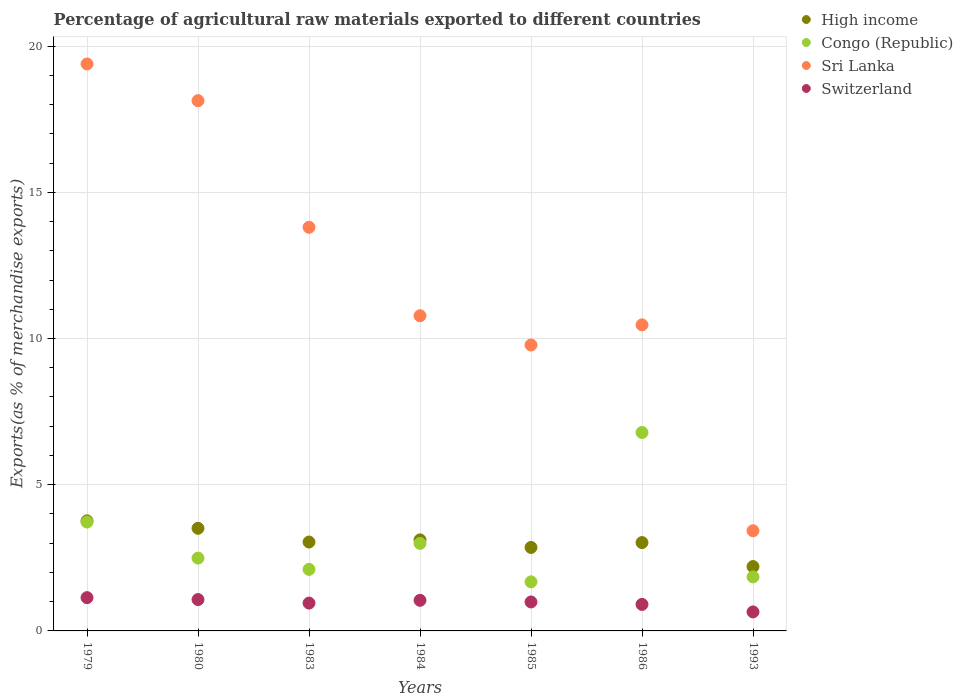How many different coloured dotlines are there?
Your answer should be compact. 4. Is the number of dotlines equal to the number of legend labels?
Keep it short and to the point. Yes. What is the percentage of exports to different countries in High income in 1984?
Your response must be concise. 3.11. Across all years, what is the maximum percentage of exports to different countries in Congo (Republic)?
Your answer should be compact. 6.79. Across all years, what is the minimum percentage of exports to different countries in Switzerland?
Provide a succinct answer. 0.65. In which year was the percentage of exports to different countries in Switzerland maximum?
Offer a very short reply. 1979. In which year was the percentage of exports to different countries in Sri Lanka minimum?
Your response must be concise. 1993. What is the total percentage of exports to different countries in Switzerland in the graph?
Make the answer very short. 6.76. What is the difference between the percentage of exports to different countries in High income in 1984 and that in 1986?
Your answer should be compact. 0.09. What is the difference between the percentage of exports to different countries in Sri Lanka in 1979 and the percentage of exports to different countries in High income in 1986?
Keep it short and to the point. 16.37. What is the average percentage of exports to different countries in High income per year?
Give a very brief answer. 3.07. In the year 1993, what is the difference between the percentage of exports to different countries in Congo (Republic) and percentage of exports to different countries in Switzerland?
Provide a short and direct response. 1.2. In how many years, is the percentage of exports to different countries in Sri Lanka greater than 16 %?
Your answer should be compact. 2. What is the ratio of the percentage of exports to different countries in Sri Lanka in 1984 to that in 1985?
Offer a very short reply. 1.1. Is the percentage of exports to different countries in Switzerland in 1980 less than that in 1983?
Provide a succinct answer. No. Is the difference between the percentage of exports to different countries in Congo (Republic) in 1980 and 1986 greater than the difference between the percentage of exports to different countries in Switzerland in 1980 and 1986?
Offer a very short reply. No. What is the difference between the highest and the second highest percentage of exports to different countries in High income?
Ensure brevity in your answer.  0.26. What is the difference between the highest and the lowest percentage of exports to different countries in Congo (Republic)?
Keep it short and to the point. 5.11. In how many years, is the percentage of exports to different countries in High income greater than the average percentage of exports to different countries in High income taken over all years?
Ensure brevity in your answer.  3. Is the sum of the percentage of exports to different countries in High income in 1984 and 1985 greater than the maximum percentage of exports to different countries in Sri Lanka across all years?
Your answer should be very brief. No. Is it the case that in every year, the sum of the percentage of exports to different countries in Switzerland and percentage of exports to different countries in Congo (Republic)  is greater than the percentage of exports to different countries in High income?
Your response must be concise. No. Does the percentage of exports to different countries in Sri Lanka monotonically increase over the years?
Make the answer very short. No. Is the percentage of exports to different countries in Sri Lanka strictly less than the percentage of exports to different countries in High income over the years?
Your answer should be very brief. No. How many dotlines are there?
Provide a short and direct response. 4. What is the difference between two consecutive major ticks on the Y-axis?
Give a very brief answer. 5. Are the values on the major ticks of Y-axis written in scientific E-notation?
Make the answer very short. No. What is the title of the graph?
Your answer should be very brief. Percentage of agricultural raw materials exported to different countries. What is the label or title of the Y-axis?
Provide a succinct answer. Exports(as % of merchandise exports). What is the Exports(as % of merchandise exports) of High income in 1979?
Your response must be concise. 3.76. What is the Exports(as % of merchandise exports) of Congo (Republic) in 1979?
Offer a very short reply. 3.72. What is the Exports(as % of merchandise exports) in Sri Lanka in 1979?
Your answer should be compact. 19.39. What is the Exports(as % of merchandise exports) of Switzerland in 1979?
Offer a terse response. 1.14. What is the Exports(as % of merchandise exports) of High income in 1980?
Give a very brief answer. 3.51. What is the Exports(as % of merchandise exports) of Congo (Republic) in 1980?
Provide a short and direct response. 2.49. What is the Exports(as % of merchandise exports) of Sri Lanka in 1980?
Give a very brief answer. 18.13. What is the Exports(as % of merchandise exports) of Switzerland in 1980?
Give a very brief answer. 1.07. What is the Exports(as % of merchandise exports) in High income in 1983?
Offer a very short reply. 3.04. What is the Exports(as % of merchandise exports) of Congo (Republic) in 1983?
Offer a terse response. 2.1. What is the Exports(as % of merchandise exports) in Sri Lanka in 1983?
Keep it short and to the point. 13.8. What is the Exports(as % of merchandise exports) in Switzerland in 1983?
Offer a terse response. 0.95. What is the Exports(as % of merchandise exports) in High income in 1984?
Your answer should be very brief. 3.11. What is the Exports(as % of merchandise exports) of Congo (Republic) in 1984?
Your answer should be compact. 2.99. What is the Exports(as % of merchandise exports) of Sri Lanka in 1984?
Provide a short and direct response. 10.78. What is the Exports(as % of merchandise exports) in Switzerland in 1984?
Your answer should be compact. 1.05. What is the Exports(as % of merchandise exports) of High income in 1985?
Offer a very short reply. 2.85. What is the Exports(as % of merchandise exports) in Congo (Republic) in 1985?
Ensure brevity in your answer.  1.68. What is the Exports(as % of merchandise exports) of Sri Lanka in 1985?
Offer a terse response. 9.78. What is the Exports(as % of merchandise exports) in Switzerland in 1985?
Offer a terse response. 0.99. What is the Exports(as % of merchandise exports) of High income in 1986?
Your answer should be very brief. 3.02. What is the Exports(as % of merchandise exports) in Congo (Republic) in 1986?
Make the answer very short. 6.79. What is the Exports(as % of merchandise exports) in Sri Lanka in 1986?
Offer a terse response. 10.47. What is the Exports(as % of merchandise exports) of Switzerland in 1986?
Offer a terse response. 0.91. What is the Exports(as % of merchandise exports) in High income in 1993?
Provide a succinct answer. 2.2. What is the Exports(as % of merchandise exports) in Congo (Republic) in 1993?
Keep it short and to the point. 1.85. What is the Exports(as % of merchandise exports) in Sri Lanka in 1993?
Offer a very short reply. 3.43. What is the Exports(as % of merchandise exports) in Switzerland in 1993?
Your answer should be very brief. 0.65. Across all years, what is the maximum Exports(as % of merchandise exports) of High income?
Provide a succinct answer. 3.76. Across all years, what is the maximum Exports(as % of merchandise exports) of Congo (Republic)?
Make the answer very short. 6.79. Across all years, what is the maximum Exports(as % of merchandise exports) in Sri Lanka?
Make the answer very short. 19.39. Across all years, what is the maximum Exports(as % of merchandise exports) of Switzerland?
Your response must be concise. 1.14. Across all years, what is the minimum Exports(as % of merchandise exports) in High income?
Ensure brevity in your answer.  2.2. Across all years, what is the minimum Exports(as % of merchandise exports) of Congo (Republic)?
Make the answer very short. 1.68. Across all years, what is the minimum Exports(as % of merchandise exports) in Sri Lanka?
Provide a succinct answer. 3.43. Across all years, what is the minimum Exports(as % of merchandise exports) of Switzerland?
Your answer should be compact. 0.65. What is the total Exports(as % of merchandise exports) of High income in the graph?
Give a very brief answer. 21.5. What is the total Exports(as % of merchandise exports) in Congo (Republic) in the graph?
Provide a succinct answer. 21.62. What is the total Exports(as % of merchandise exports) in Sri Lanka in the graph?
Provide a succinct answer. 85.77. What is the total Exports(as % of merchandise exports) of Switzerland in the graph?
Keep it short and to the point. 6.76. What is the difference between the Exports(as % of merchandise exports) in High income in 1979 and that in 1980?
Offer a very short reply. 0.26. What is the difference between the Exports(as % of merchandise exports) in Congo (Republic) in 1979 and that in 1980?
Provide a short and direct response. 1.23. What is the difference between the Exports(as % of merchandise exports) in Sri Lanka in 1979 and that in 1980?
Your answer should be very brief. 1.25. What is the difference between the Exports(as % of merchandise exports) in Switzerland in 1979 and that in 1980?
Give a very brief answer. 0.07. What is the difference between the Exports(as % of merchandise exports) of High income in 1979 and that in 1983?
Your answer should be compact. 0.73. What is the difference between the Exports(as % of merchandise exports) of Congo (Republic) in 1979 and that in 1983?
Ensure brevity in your answer.  1.62. What is the difference between the Exports(as % of merchandise exports) of Sri Lanka in 1979 and that in 1983?
Offer a terse response. 5.58. What is the difference between the Exports(as % of merchandise exports) in Switzerland in 1979 and that in 1983?
Your answer should be compact. 0.19. What is the difference between the Exports(as % of merchandise exports) of High income in 1979 and that in 1984?
Offer a very short reply. 0.65. What is the difference between the Exports(as % of merchandise exports) of Congo (Republic) in 1979 and that in 1984?
Give a very brief answer. 0.73. What is the difference between the Exports(as % of merchandise exports) of Sri Lanka in 1979 and that in 1984?
Keep it short and to the point. 8.61. What is the difference between the Exports(as % of merchandise exports) in Switzerland in 1979 and that in 1984?
Ensure brevity in your answer.  0.09. What is the difference between the Exports(as % of merchandise exports) of High income in 1979 and that in 1985?
Make the answer very short. 0.91. What is the difference between the Exports(as % of merchandise exports) of Congo (Republic) in 1979 and that in 1985?
Your answer should be compact. 2.04. What is the difference between the Exports(as % of merchandise exports) in Sri Lanka in 1979 and that in 1985?
Your response must be concise. 9.61. What is the difference between the Exports(as % of merchandise exports) of Switzerland in 1979 and that in 1985?
Give a very brief answer. 0.15. What is the difference between the Exports(as % of merchandise exports) in High income in 1979 and that in 1986?
Your response must be concise. 0.74. What is the difference between the Exports(as % of merchandise exports) of Congo (Republic) in 1979 and that in 1986?
Offer a very short reply. -3.06. What is the difference between the Exports(as % of merchandise exports) in Sri Lanka in 1979 and that in 1986?
Make the answer very short. 8.92. What is the difference between the Exports(as % of merchandise exports) in Switzerland in 1979 and that in 1986?
Make the answer very short. 0.23. What is the difference between the Exports(as % of merchandise exports) in High income in 1979 and that in 1993?
Your answer should be very brief. 1.56. What is the difference between the Exports(as % of merchandise exports) of Congo (Republic) in 1979 and that in 1993?
Your response must be concise. 1.87. What is the difference between the Exports(as % of merchandise exports) in Sri Lanka in 1979 and that in 1993?
Your response must be concise. 15.96. What is the difference between the Exports(as % of merchandise exports) of Switzerland in 1979 and that in 1993?
Your answer should be very brief. 0.49. What is the difference between the Exports(as % of merchandise exports) of High income in 1980 and that in 1983?
Keep it short and to the point. 0.47. What is the difference between the Exports(as % of merchandise exports) of Congo (Republic) in 1980 and that in 1983?
Ensure brevity in your answer.  0.39. What is the difference between the Exports(as % of merchandise exports) in Sri Lanka in 1980 and that in 1983?
Provide a succinct answer. 4.33. What is the difference between the Exports(as % of merchandise exports) of Switzerland in 1980 and that in 1983?
Provide a short and direct response. 0.12. What is the difference between the Exports(as % of merchandise exports) of High income in 1980 and that in 1984?
Offer a very short reply. 0.4. What is the difference between the Exports(as % of merchandise exports) in Congo (Republic) in 1980 and that in 1984?
Ensure brevity in your answer.  -0.5. What is the difference between the Exports(as % of merchandise exports) in Sri Lanka in 1980 and that in 1984?
Offer a terse response. 7.35. What is the difference between the Exports(as % of merchandise exports) of Switzerland in 1980 and that in 1984?
Keep it short and to the point. 0.03. What is the difference between the Exports(as % of merchandise exports) in High income in 1980 and that in 1985?
Your answer should be very brief. 0.65. What is the difference between the Exports(as % of merchandise exports) in Congo (Republic) in 1980 and that in 1985?
Your answer should be very brief. 0.81. What is the difference between the Exports(as % of merchandise exports) of Sri Lanka in 1980 and that in 1985?
Provide a short and direct response. 8.36. What is the difference between the Exports(as % of merchandise exports) of Switzerland in 1980 and that in 1985?
Give a very brief answer. 0.08. What is the difference between the Exports(as % of merchandise exports) of High income in 1980 and that in 1986?
Offer a very short reply. 0.49. What is the difference between the Exports(as % of merchandise exports) in Congo (Republic) in 1980 and that in 1986?
Ensure brevity in your answer.  -4.3. What is the difference between the Exports(as % of merchandise exports) of Sri Lanka in 1980 and that in 1986?
Give a very brief answer. 7.67. What is the difference between the Exports(as % of merchandise exports) of Switzerland in 1980 and that in 1986?
Provide a short and direct response. 0.17. What is the difference between the Exports(as % of merchandise exports) of High income in 1980 and that in 1993?
Provide a short and direct response. 1.31. What is the difference between the Exports(as % of merchandise exports) in Congo (Republic) in 1980 and that in 1993?
Keep it short and to the point. 0.64. What is the difference between the Exports(as % of merchandise exports) in Sri Lanka in 1980 and that in 1993?
Keep it short and to the point. 14.71. What is the difference between the Exports(as % of merchandise exports) in Switzerland in 1980 and that in 1993?
Offer a terse response. 0.42. What is the difference between the Exports(as % of merchandise exports) of High income in 1983 and that in 1984?
Offer a terse response. -0.07. What is the difference between the Exports(as % of merchandise exports) in Congo (Republic) in 1983 and that in 1984?
Your answer should be compact. -0.89. What is the difference between the Exports(as % of merchandise exports) of Sri Lanka in 1983 and that in 1984?
Make the answer very short. 3.02. What is the difference between the Exports(as % of merchandise exports) in Switzerland in 1983 and that in 1984?
Keep it short and to the point. -0.09. What is the difference between the Exports(as % of merchandise exports) of High income in 1983 and that in 1985?
Provide a short and direct response. 0.18. What is the difference between the Exports(as % of merchandise exports) in Congo (Republic) in 1983 and that in 1985?
Give a very brief answer. 0.43. What is the difference between the Exports(as % of merchandise exports) in Sri Lanka in 1983 and that in 1985?
Offer a very short reply. 4.03. What is the difference between the Exports(as % of merchandise exports) in Switzerland in 1983 and that in 1985?
Provide a succinct answer. -0.04. What is the difference between the Exports(as % of merchandise exports) in High income in 1983 and that in 1986?
Your response must be concise. 0.02. What is the difference between the Exports(as % of merchandise exports) in Congo (Republic) in 1983 and that in 1986?
Offer a terse response. -4.68. What is the difference between the Exports(as % of merchandise exports) of Sri Lanka in 1983 and that in 1986?
Ensure brevity in your answer.  3.34. What is the difference between the Exports(as % of merchandise exports) in Switzerland in 1983 and that in 1986?
Your answer should be compact. 0.04. What is the difference between the Exports(as % of merchandise exports) of High income in 1983 and that in 1993?
Your answer should be compact. 0.84. What is the difference between the Exports(as % of merchandise exports) of Congo (Republic) in 1983 and that in 1993?
Offer a very short reply. 0.26. What is the difference between the Exports(as % of merchandise exports) of Sri Lanka in 1983 and that in 1993?
Offer a terse response. 10.38. What is the difference between the Exports(as % of merchandise exports) of Switzerland in 1983 and that in 1993?
Your answer should be very brief. 0.3. What is the difference between the Exports(as % of merchandise exports) in High income in 1984 and that in 1985?
Offer a terse response. 0.26. What is the difference between the Exports(as % of merchandise exports) of Congo (Republic) in 1984 and that in 1985?
Your answer should be compact. 1.32. What is the difference between the Exports(as % of merchandise exports) of Sri Lanka in 1984 and that in 1985?
Provide a succinct answer. 1. What is the difference between the Exports(as % of merchandise exports) of Switzerland in 1984 and that in 1985?
Offer a very short reply. 0.06. What is the difference between the Exports(as % of merchandise exports) in High income in 1984 and that in 1986?
Your response must be concise. 0.09. What is the difference between the Exports(as % of merchandise exports) of Congo (Republic) in 1984 and that in 1986?
Make the answer very short. -3.79. What is the difference between the Exports(as % of merchandise exports) of Sri Lanka in 1984 and that in 1986?
Ensure brevity in your answer.  0.31. What is the difference between the Exports(as % of merchandise exports) of Switzerland in 1984 and that in 1986?
Keep it short and to the point. 0.14. What is the difference between the Exports(as % of merchandise exports) in High income in 1984 and that in 1993?
Offer a very short reply. 0.91. What is the difference between the Exports(as % of merchandise exports) of Congo (Republic) in 1984 and that in 1993?
Keep it short and to the point. 1.15. What is the difference between the Exports(as % of merchandise exports) of Sri Lanka in 1984 and that in 1993?
Provide a succinct answer. 7.35. What is the difference between the Exports(as % of merchandise exports) in Switzerland in 1984 and that in 1993?
Your answer should be compact. 0.4. What is the difference between the Exports(as % of merchandise exports) in High income in 1985 and that in 1986?
Offer a terse response. -0.17. What is the difference between the Exports(as % of merchandise exports) of Congo (Republic) in 1985 and that in 1986?
Your answer should be compact. -5.11. What is the difference between the Exports(as % of merchandise exports) in Sri Lanka in 1985 and that in 1986?
Offer a very short reply. -0.69. What is the difference between the Exports(as % of merchandise exports) in Switzerland in 1985 and that in 1986?
Offer a terse response. 0.08. What is the difference between the Exports(as % of merchandise exports) in High income in 1985 and that in 1993?
Provide a short and direct response. 0.65. What is the difference between the Exports(as % of merchandise exports) in Congo (Republic) in 1985 and that in 1993?
Ensure brevity in your answer.  -0.17. What is the difference between the Exports(as % of merchandise exports) in Sri Lanka in 1985 and that in 1993?
Ensure brevity in your answer.  6.35. What is the difference between the Exports(as % of merchandise exports) in Switzerland in 1985 and that in 1993?
Your answer should be compact. 0.34. What is the difference between the Exports(as % of merchandise exports) in High income in 1986 and that in 1993?
Give a very brief answer. 0.82. What is the difference between the Exports(as % of merchandise exports) in Congo (Republic) in 1986 and that in 1993?
Provide a succinct answer. 4.94. What is the difference between the Exports(as % of merchandise exports) in Sri Lanka in 1986 and that in 1993?
Keep it short and to the point. 7.04. What is the difference between the Exports(as % of merchandise exports) of Switzerland in 1986 and that in 1993?
Give a very brief answer. 0.26. What is the difference between the Exports(as % of merchandise exports) of High income in 1979 and the Exports(as % of merchandise exports) of Congo (Republic) in 1980?
Provide a succinct answer. 1.27. What is the difference between the Exports(as % of merchandise exports) in High income in 1979 and the Exports(as % of merchandise exports) in Sri Lanka in 1980?
Offer a terse response. -14.37. What is the difference between the Exports(as % of merchandise exports) of High income in 1979 and the Exports(as % of merchandise exports) of Switzerland in 1980?
Ensure brevity in your answer.  2.69. What is the difference between the Exports(as % of merchandise exports) of Congo (Republic) in 1979 and the Exports(as % of merchandise exports) of Sri Lanka in 1980?
Make the answer very short. -14.41. What is the difference between the Exports(as % of merchandise exports) of Congo (Republic) in 1979 and the Exports(as % of merchandise exports) of Switzerland in 1980?
Your response must be concise. 2.65. What is the difference between the Exports(as % of merchandise exports) in Sri Lanka in 1979 and the Exports(as % of merchandise exports) in Switzerland in 1980?
Keep it short and to the point. 18.32. What is the difference between the Exports(as % of merchandise exports) in High income in 1979 and the Exports(as % of merchandise exports) in Congo (Republic) in 1983?
Your response must be concise. 1.66. What is the difference between the Exports(as % of merchandise exports) of High income in 1979 and the Exports(as % of merchandise exports) of Sri Lanka in 1983?
Your answer should be very brief. -10.04. What is the difference between the Exports(as % of merchandise exports) of High income in 1979 and the Exports(as % of merchandise exports) of Switzerland in 1983?
Offer a terse response. 2.81. What is the difference between the Exports(as % of merchandise exports) in Congo (Republic) in 1979 and the Exports(as % of merchandise exports) in Sri Lanka in 1983?
Make the answer very short. -10.08. What is the difference between the Exports(as % of merchandise exports) in Congo (Republic) in 1979 and the Exports(as % of merchandise exports) in Switzerland in 1983?
Your answer should be compact. 2.77. What is the difference between the Exports(as % of merchandise exports) of Sri Lanka in 1979 and the Exports(as % of merchandise exports) of Switzerland in 1983?
Offer a terse response. 18.44. What is the difference between the Exports(as % of merchandise exports) of High income in 1979 and the Exports(as % of merchandise exports) of Congo (Republic) in 1984?
Give a very brief answer. 0.77. What is the difference between the Exports(as % of merchandise exports) of High income in 1979 and the Exports(as % of merchandise exports) of Sri Lanka in 1984?
Make the answer very short. -7.01. What is the difference between the Exports(as % of merchandise exports) in High income in 1979 and the Exports(as % of merchandise exports) in Switzerland in 1984?
Give a very brief answer. 2.72. What is the difference between the Exports(as % of merchandise exports) of Congo (Republic) in 1979 and the Exports(as % of merchandise exports) of Sri Lanka in 1984?
Your response must be concise. -7.06. What is the difference between the Exports(as % of merchandise exports) of Congo (Republic) in 1979 and the Exports(as % of merchandise exports) of Switzerland in 1984?
Provide a short and direct response. 2.68. What is the difference between the Exports(as % of merchandise exports) of Sri Lanka in 1979 and the Exports(as % of merchandise exports) of Switzerland in 1984?
Provide a succinct answer. 18.34. What is the difference between the Exports(as % of merchandise exports) in High income in 1979 and the Exports(as % of merchandise exports) in Congo (Republic) in 1985?
Give a very brief answer. 2.09. What is the difference between the Exports(as % of merchandise exports) of High income in 1979 and the Exports(as % of merchandise exports) of Sri Lanka in 1985?
Offer a very short reply. -6.01. What is the difference between the Exports(as % of merchandise exports) of High income in 1979 and the Exports(as % of merchandise exports) of Switzerland in 1985?
Your response must be concise. 2.77. What is the difference between the Exports(as % of merchandise exports) of Congo (Republic) in 1979 and the Exports(as % of merchandise exports) of Sri Lanka in 1985?
Your answer should be very brief. -6.05. What is the difference between the Exports(as % of merchandise exports) in Congo (Republic) in 1979 and the Exports(as % of merchandise exports) in Switzerland in 1985?
Offer a terse response. 2.73. What is the difference between the Exports(as % of merchandise exports) of Sri Lanka in 1979 and the Exports(as % of merchandise exports) of Switzerland in 1985?
Your response must be concise. 18.4. What is the difference between the Exports(as % of merchandise exports) in High income in 1979 and the Exports(as % of merchandise exports) in Congo (Republic) in 1986?
Your answer should be very brief. -3.02. What is the difference between the Exports(as % of merchandise exports) in High income in 1979 and the Exports(as % of merchandise exports) in Sri Lanka in 1986?
Offer a terse response. -6.7. What is the difference between the Exports(as % of merchandise exports) in High income in 1979 and the Exports(as % of merchandise exports) in Switzerland in 1986?
Provide a succinct answer. 2.86. What is the difference between the Exports(as % of merchandise exports) in Congo (Republic) in 1979 and the Exports(as % of merchandise exports) in Sri Lanka in 1986?
Make the answer very short. -6.74. What is the difference between the Exports(as % of merchandise exports) of Congo (Republic) in 1979 and the Exports(as % of merchandise exports) of Switzerland in 1986?
Make the answer very short. 2.82. What is the difference between the Exports(as % of merchandise exports) of Sri Lanka in 1979 and the Exports(as % of merchandise exports) of Switzerland in 1986?
Your answer should be very brief. 18.48. What is the difference between the Exports(as % of merchandise exports) of High income in 1979 and the Exports(as % of merchandise exports) of Congo (Republic) in 1993?
Keep it short and to the point. 1.92. What is the difference between the Exports(as % of merchandise exports) in High income in 1979 and the Exports(as % of merchandise exports) in Sri Lanka in 1993?
Your answer should be very brief. 0.34. What is the difference between the Exports(as % of merchandise exports) in High income in 1979 and the Exports(as % of merchandise exports) in Switzerland in 1993?
Provide a short and direct response. 3.11. What is the difference between the Exports(as % of merchandise exports) of Congo (Republic) in 1979 and the Exports(as % of merchandise exports) of Sri Lanka in 1993?
Offer a very short reply. 0.3. What is the difference between the Exports(as % of merchandise exports) in Congo (Republic) in 1979 and the Exports(as % of merchandise exports) in Switzerland in 1993?
Your response must be concise. 3.07. What is the difference between the Exports(as % of merchandise exports) of Sri Lanka in 1979 and the Exports(as % of merchandise exports) of Switzerland in 1993?
Offer a terse response. 18.74. What is the difference between the Exports(as % of merchandise exports) of High income in 1980 and the Exports(as % of merchandise exports) of Congo (Republic) in 1983?
Your answer should be very brief. 1.41. What is the difference between the Exports(as % of merchandise exports) in High income in 1980 and the Exports(as % of merchandise exports) in Sri Lanka in 1983?
Your answer should be compact. -10.29. What is the difference between the Exports(as % of merchandise exports) in High income in 1980 and the Exports(as % of merchandise exports) in Switzerland in 1983?
Give a very brief answer. 2.56. What is the difference between the Exports(as % of merchandise exports) in Congo (Republic) in 1980 and the Exports(as % of merchandise exports) in Sri Lanka in 1983?
Provide a succinct answer. -11.31. What is the difference between the Exports(as % of merchandise exports) of Congo (Republic) in 1980 and the Exports(as % of merchandise exports) of Switzerland in 1983?
Keep it short and to the point. 1.54. What is the difference between the Exports(as % of merchandise exports) of Sri Lanka in 1980 and the Exports(as % of merchandise exports) of Switzerland in 1983?
Offer a terse response. 17.18. What is the difference between the Exports(as % of merchandise exports) in High income in 1980 and the Exports(as % of merchandise exports) in Congo (Republic) in 1984?
Make the answer very short. 0.52. What is the difference between the Exports(as % of merchandise exports) of High income in 1980 and the Exports(as % of merchandise exports) of Sri Lanka in 1984?
Keep it short and to the point. -7.27. What is the difference between the Exports(as % of merchandise exports) in High income in 1980 and the Exports(as % of merchandise exports) in Switzerland in 1984?
Provide a succinct answer. 2.46. What is the difference between the Exports(as % of merchandise exports) of Congo (Republic) in 1980 and the Exports(as % of merchandise exports) of Sri Lanka in 1984?
Offer a very short reply. -8.29. What is the difference between the Exports(as % of merchandise exports) in Congo (Republic) in 1980 and the Exports(as % of merchandise exports) in Switzerland in 1984?
Offer a terse response. 1.44. What is the difference between the Exports(as % of merchandise exports) of Sri Lanka in 1980 and the Exports(as % of merchandise exports) of Switzerland in 1984?
Make the answer very short. 17.09. What is the difference between the Exports(as % of merchandise exports) of High income in 1980 and the Exports(as % of merchandise exports) of Congo (Republic) in 1985?
Keep it short and to the point. 1.83. What is the difference between the Exports(as % of merchandise exports) of High income in 1980 and the Exports(as % of merchandise exports) of Sri Lanka in 1985?
Ensure brevity in your answer.  -6.27. What is the difference between the Exports(as % of merchandise exports) of High income in 1980 and the Exports(as % of merchandise exports) of Switzerland in 1985?
Offer a terse response. 2.52. What is the difference between the Exports(as % of merchandise exports) of Congo (Republic) in 1980 and the Exports(as % of merchandise exports) of Sri Lanka in 1985?
Provide a short and direct response. -7.29. What is the difference between the Exports(as % of merchandise exports) of Congo (Republic) in 1980 and the Exports(as % of merchandise exports) of Switzerland in 1985?
Provide a short and direct response. 1.5. What is the difference between the Exports(as % of merchandise exports) in Sri Lanka in 1980 and the Exports(as % of merchandise exports) in Switzerland in 1985?
Offer a very short reply. 17.14. What is the difference between the Exports(as % of merchandise exports) in High income in 1980 and the Exports(as % of merchandise exports) in Congo (Republic) in 1986?
Keep it short and to the point. -3.28. What is the difference between the Exports(as % of merchandise exports) of High income in 1980 and the Exports(as % of merchandise exports) of Sri Lanka in 1986?
Keep it short and to the point. -6.96. What is the difference between the Exports(as % of merchandise exports) of High income in 1980 and the Exports(as % of merchandise exports) of Switzerland in 1986?
Offer a terse response. 2.6. What is the difference between the Exports(as % of merchandise exports) of Congo (Republic) in 1980 and the Exports(as % of merchandise exports) of Sri Lanka in 1986?
Provide a succinct answer. -7.98. What is the difference between the Exports(as % of merchandise exports) of Congo (Republic) in 1980 and the Exports(as % of merchandise exports) of Switzerland in 1986?
Your answer should be compact. 1.58. What is the difference between the Exports(as % of merchandise exports) in Sri Lanka in 1980 and the Exports(as % of merchandise exports) in Switzerland in 1986?
Offer a very short reply. 17.23. What is the difference between the Exports(as % of merchandise exports) of High income in 1980 and the Exports(as % of merchandise exports) of Congo (Republic) in 1993?
Provide a succinct answer. 1.66. What is the difference between the Exports(as % of merchandise exports) of High income in 1980 and the Exports(as % of merchandise exports) of Sri Lanka in 1993?
Give a very brief answer. 0.08. What is the difference between the Exports(as % of merchandise exports) in High income in 1980 and the Exports(as % of merchandise exports) in Switzerland in 1993?
Provide a succinct answer. 2.86. What is the difference between the Exports(as % of merchandise exports) in Congo (Republic) in 1980 and the Exports(as % of merchandise exports) in Sri Lanka in 1993?
Keep it short and to the point. -0.93. What is the difference between the Exports(as % of merchandise exports) in Congo (Republic) in 1980 and the Exports(as % of merchandise exports) in Switzerland in 1993?
Offer a very short reply. 1.84. What is the difference between the Exports(as % of merchandise exports) in Sri Lanka in 1980 and the Exports(as % of merchandise exports) in Switzerland in 1993?
Make the answer very short. 17.48. What is the difference between the Exports(as % of merchandise exports) of High income in 1983 and the Exports(as % of merchandise exports) of Congo (Republic) in 1984?
Offer a very short reply. 0.05. What is the difference between the Exports(as % of merchandise exports) of High income in 1983 and the Exports(as % of merchandise exports) of Sri Lanka in 1984?
Offer a terse response. -7.74. What is the difference between the Exports(as % of merchandise exports) of High income in 1983 and the Exports(as % of merchandise exports) of Switzerland in 1984?
Give a very brief answer. 1.99. What is the difference between the Exports(as % of merchandise exports) in Congo (Republic) in 1983 and the Exports(as % of merchandise exports) in Sri Lanka in 1984?
Your response must be concise. -8.67. What is the difference between the Exports(as % of merchandise exports) in Congo (Republic) in 1983 and the Exports(as % of merchandise exports) in Switzerland in 1984?
Keep it short and to the point. 1.06. What is the difference between the Exports(as % of merchandise exports) of Sri Lanka in 1983 and the Exports(as % of merchandise exports) of Switzerland in 1984?
Your answer should be compact. 12.76. What is the difference between the Exports(as % of merchandise exports) in High income in 1983 and the Exports(as % of merchandise exports) in Congo (Republic) in 1985?
Ensure brevity in your answer.  1.36. What is the difference between the Exports(as % of merchandise exports) of High income in 1983 and the Exports(as % of merchandise exports) of Sri Lanka in 1985?
Provide a short and direct response. -6.74. What is the difference between the Exports(as % of merchandise exports) in High income in 1983 and the Exports(as % of merchandise exports) in Switzerland in 1985?
Provide a succinct answer. 2.05. What is the difference between the Exports(as % of merchandise exports) in Congo (Republic) in 1983 and the Exports(as % of merchandise exports) in Sri Lanka in 1985?
Keep it short and to the point. -7.67. What is the difference between the Exports(as % of merchandise exports) in Congo (Republic) in 1983 and the Exports(as % of merchandise exports) in Switzerland in 1985?
Your answer should be very brief. 1.11. What is the difference between the Exports(as % of merchandise exports) in Sri Lanka in 1983 and the Exports(as % of merchandise exports) in Switzerland in 1985?
Make the answer very short. 12.81. What is the difference between the Exports(as % of merchandise exports) of High income in 1983 and the Exports(as % of merchandise exports) of Congo (Republic) in 1986?
Provide a short and direct response. -3.75. What is the difference between the Exports(as % of merchandise exports) of High income in 1983 and the Exports(as % of merchandise exports) of Sri Lanka in 1986?
Provide a succinct answer. -7.43. What is the difference between the Exports(as % of merchandise exports) of High income in 1983 and the Exports(as % of merchandise exports) of Switzerland in 1986?
Provide a succinct answer. 2.13. What is the difference between the Exports(as % of merchandise exports) in Congo (Republic) in 1983 and the Exports(as % of merchandise exports) in Sri Lanka in 1986?
Give a very brief answer. -8.36. What is the difference between the Exports(as % of merchandise exports) of Congo (Republic) in 1983 and the Exports(as % of merchandise exports) of Switzerland in 1986?
Your response must be concise. 1.2. What is the difference between the Exports(as % of merchandise exports) in Sri Lanka in 1983 and the Exports(as % of merchandise exports) in Switzerland in 1986?
Your answer should be compact. 12.9. What is the difference between the Exports(as % of merchandise exports) of High income in 1983 and the Exports(as % of merchandise exports) of Congo (Republic) in 1993?
Offer a very short reply. 1.19. What is the difference between the Exports(as % of merchandise exports) of High income in 1983 and the Exports(as % of merchandise exports) of Sri Lanka in 1993?
Ensure brevity in your answer.  -0.39. What is the difference between the Exports(as % of merchandise exports) of High income in 1983 and the Exports(as % of merchandise exports) of Switzerland in 1993?
Keep it short and to the point. 2.39. What is the difference between the Exports(as % of merchandise exports) of Congo (Republic) in 1983 and the Exports(as % of merchandise exports) of Sri Lanka in 1993?
Make the answer very short. -1.32. What is the difference between the Exports(as % of merchandise exports) in Congo (Republic) in 1983 and the Exports(as % of merchandise exports) in Switzerland in 1993?
Your response must be concise. 1.45. What is the difference between the Exports(as % of merchandise exports) in Sri Lanka in 1983 and the Exports(as % of merchandise exports) in Switzerland in 1993?
Your answer should be compact. 13.15. What is the difference between the Exports(as % of merchandise exports) in High income in 1984 and the Exports(as % of merchandise exports) in Congo (Republic) in 1985?
Make the answer very short. 1.44. What is the difference between the Exports(as % of merchandise exports) in High income in 1984 and the Exports(as % of merchandise exports) in Sri Lanka in 1985?
Provide a short and direct response. -6.66. What is the difference between the Exports(as % of merchandise exports) of High income in 1984 and the Exports(as % of merchandise exports) of Switzerland in 1985?
Your response must be concise. 2.12. What is the difference between the Exports(as % of merchandise exports) in Congo (Republic) in 1984 and the Exports(as % of merchandise exports) in Sri Lanka in 1985?
Offer a very short reply. -6.78. What is the difference between the Exports(as % of merchandise exports) in Congo (Republic) in 1984 and the Exports(as % of merchandise exports) in Switzerland in 1985?
Provide a short and direct response. 2. What is the difference between the Exports(as % of merchandise exports) in Sri Lanka in 1984 and the Exports(as % of merchandise exports) in Switzerland in 1985?
Provide a short and direct response. 9.79. What is the difference between the Exports(as % of merchandise exports) in High income in 1984 and the Exports(as % of merchandise exports) in Congo (Republic) in 1986?
Offer a very short reply. -3.67. What is the difference between the Exports(as % of merchandise exports) in High income in 1984 and the Exports(as % of merchandise exports) in Sri Lanka in 1986?
Your answer should be compact. -7.35. What is the difference between the Exports(as % of merchandise exports) in High income in 1984 and the Exports(as % of merchandise exports) in Switzerland in 1986?
Your answer should be very brief. 2.21. What is the difference between the Exports(as % of merchandise exports) of Congo (Republic) in 1984 and the Exports(as % of merchandise exports) of Sri Lanka in 1986?
Make the answer very short. -7.47. What is the difference between the Exports(as % of merchandise exports) of Congo (Republic) in 1984 and the Exports(as % of merchandise exports) of Switzerland in 1986?
Give a very brief answer. 2.09. What is the difference between the Exports(as % of merchandise exports) of Sri Lanka in 1984 and the Exports(as % of merchandise exports) of Switzerland in 1986?
Provide a short and direct response. 9.87. What is the difference between the Exports(as % of merchandise exports) of High income in 1984 and the Exports(as % of merchandise exports) of Congo (Republic) in 1993?
Offer a terse response. 1.27. What is the difference between the Exports(as % of merchandise exports) of High income in 1984 and the Exports(as % of merchandise exports) of Sri Lanka in 1993?
Give a very brief answer. -0.31. What is the difference between the Exports(as % of merchandise exports) in High income in 1984 and the Exports(as % of merchandise exports) in Switzerland in 1993?
Make the answer very short. 2.46. What is the difference between the Exports(as % of merchandise exports) in Congo (Republic) in 1984 and the Exports(as % of merchandise exports) in Sri Lanka in 1993?
Offer a terse response. -0.43. What is the difference between the Exports(as % of merchandise exports) of Congo (Republic) in 1984 and the Exports(as % of merchandise exports) of Switzerland in 1993?
Keep it short and to the point. 2.34. What is the difference between the Exports(as % of merchandise exports) of Sri Lanka in 1984 and the Exports(as % of merchandise exports) of Switzerland in 1993?
Offer a very short reply. 10.13. What is the difference between the Exports(as % of merchandise exports) of High income in 1985 and the Exports(as % of merchandise exports) of Congo (Republic) in 1986?
Your answer should be compact. -3.93. What is the difference between the Exports(as % of merchandise exports) in High income in 1985 and the Exports(as % of merchandise exports) in Sri Lanka in 1986?
Provide a short and direct response. -7.61. What is the difference between the Exports(as % of merchandise exports) of High income in 1985 and the Exports(as % of merchandise exports) of Switzerland in 1986?
Your answer should be very brief. 1.95. What is the difference between the Exports(as % of merchandise exports) of Congo (Republic) in 1985 and the Exports(as % of merchandise exports) of Sri Lanka in 1986?
Your answer should be very brief. -8.79. What is the difference between the Exports(as % of merchandise exports) in Congo (Republic) in 1985 and the Exports(as % of merchandise exports) in Switzerland in 1986?
Ensure brevity in your answer.  0.77. What is the difference between the Exports(as % of merchandise exports) of Sri Lanka in 1985 and the Exports(as % of merchandise exports) of Switzerland in 1986?
Offer a very short reply. 8.87. What is the difference between the Exports(as % of merchandise exports) in High income in 1985 and the Exports(as % of merchandise exports) in Sri Lanka in 1993?
Provide a succinct answer. -0.57. What is the difference between the Exports(as % of merchandise exports) in High income in 1985 and the Exports(as % of merchandise exports) in Switzerland in 1993?
Keep it short and to the point. 2.2. What is the difference between the Exports(as % of merchandise exports) in Congo (Republic) in 1985 and the Exports(as % of merchandise exports) in Sri Lanka in 1993?
Provide a succinct answer. -1.75. What is the difference between the Exports(as % of merchandise exports) of Congo (Republic) in 1985 and the Exports(as % of merchandise exports) of Switzerland in 1993?
Keep it short and to the point. 1.03. What is the difference between the Exports(as % of merchandise exports) of Sri Lanka in 1985 and the Exports(as % of merchandise exports) of Switzerland in 1993?
Make the answer very short. 9.13. What is the difference between the Exports(as % of merchandise exports) in High income in 1986 and the Exports(as % of merchandise exports) in Congo (Republic) in 1993?
Keep it short and to the point. 1.17. What is the difference between the Exports(as % of merchandise exports) in High income in 1986 and the Exports(as % of merchandise exports) in Sri Lanka in 1993?
Keep it short and to the point. -0.4. What is the difference between the Exports(as % of merchandise exports) of High income in 1986 and the Exports(as % of merchandise exports) of Switzerland in 1993?
Your answer should be compact. 2.37. What is the difference between the Exports(as % of merchandise exports) in Congo (Republic) in 1986 and the Exports(as % of merchandise exports) in Sri Lanka in 1993?
Offer a terse response. 3.36. What is the difference between the Exports(as % of merchandise exports) of Congo (Republic) in 1986 and the Exports(as % of merchandise exports) of Switzerland in 1993?
Your answer should be very brief. 6.14. What is the difference between the Exports(as % of merchandise exports) of Sri Lanka in 1986 and the Exports(as % of merchandise exports) of Switzerland in 1993?
Give a very brief answer. 9.82. What is the average Exports(as % of merchandise exports) of High income per year?
Provide a short and direct response. 3.07. What is the average Exports(as % of merchandise exports) of Congo (Republic) per year?
Ensure brevity in your answer.  3.09. What is the average Exports(as % of merchandise exports) in Sri Lanka per year?
Give a very brief answer. 12.25. What is the average Exports(as % of merchandise exports) of Switzerland per year?
Your response must be concise. 0.97. In the year 1979, what is the difference between the Exports(as % of merchandise exports) in High income and Exports(as % of merchandise exports) in Congo (Republic)?
Your answer should be compact. 0.04. In the year 1979, what is the difference between the Exports(as % of merchandise exports) in High income and Exports(as % of merchandise exports) in Sri Lanka?
Your response must be concise. -15.62. In the year 1979, what is the difference between the Exports(as % of merchandise exports) in High income and Exports(as % of merchandise exports) in Switzerland?
Your answer should be very brief. 2.63. In the year 1979, what is the difference between the Exports(as % of merchandise exports) of Congo (Republic) and Exports(as % of merchandise exports) of Sri Lanka?
Give a very brief answer. -15.67. In the year 1979, what is the difference between the Exports(as % of merchandise exports) in Congo (Republic) and Exports(as % of merchandise exports) in Switzerland?
Offer a very short reply. 2.58. In the year 1979, what is the difference between the Exports(as % of merchandise exports) of Sri Lanka and Exports(as % of merchandise exports) of Switzerland?
Offer a terse response. 18.25. In the year 1980, what is the difference between the Exports(as % of merchandise exports) in High income and Exports(as % of merchandise exports) in Congo (Republic)?
Offer a very short reply. 1.02. In the year 1980, what is the difference between the Exports(as % of merchandise exports) of High income and Exports(as % of merchandise exports) of Sri Lanka?
Make the answer very short. -14.62. In the year 1980, what is the difference between the Exports(as % of merchandise exports) in High income and Exports(as % of merchandise exports) in Switzerland?
Ensure brevity in your answer.  2.44. In the year 1980, what is the difference between the Exports(as % of merchandise exports) of Congo (Republic) and Exports(as % of merchandise exports) of Sri Lanka?
Provide a short and direct response. -15.64. In the year 1980, what is the difference between the Exports(as % of merchandise exports) in Congo (Republic) and Exports(as % of merchandise exports) in Switzerland?
Provide a succinct answer. 1.42. In the year 1980, what is the difference between the Exports(as % of merchandise exports) in Sri Lanka and Exports(as % of merchandise exports) in Switzerland?
Give a very brief answer. 17.06. In the year 1983, what is the difference between the Exports(as % of merchandise exports) of High income and Exports(as % of merchandise exports) of Congo (Republic)?
Offer a terse response. 0.94. In the year 1983, what is the difference between the Exports(as % of merchandise exports) in High income and Exports(as % of merchandise exports) in Sri Lanka?
Your response must be concise. -10.76. In the year 1983, what is the difference between the Exports(as % of merchandise exports) of High income and Exports(as % of merchandise exports) of Switzerland?
Ensure brevity in your answer.  2.09. In the year 1983, what is the difference between the Exports(as % of merchandise exports) in Congo (Republic) and Exports(as % of merchandise exports) in Sri Lanka?
Provide a short and direct response. -11.7. In the year 1983, what is the difference between the Exports(as % of merchandise exports) of Congo (Republic) and Exports(as % of merchandise exports) of Switzerland?
Offer a terse response. 1.15. In the year 1983, what is the difference between the Exports(as % of merchandise exports) of Sri Lanka and Exports(as % of merchandise exports) of Switzerland?
Make the answer very short. 12.85. In the year 1984, what is the difference between the Exports(as % of merchandise exports) in High income and Exports(as % of merchandise exports) in Congo (Republic)?
Your response must be concise. 0.12. In the year 1984, what is the difference between the Exports(as % of merchandise exports) in High income and Exports(as % of merchandise exports) in Sri Lanka?
Ensure brevity in your answer.  -7.66. In the year 1984, what is the difference between the Exports(as % of merchandise exports) of High income and Exports(as % of merchandise exports) of Switzerland?
Provide a short and direct response. 2.07. In the year 1984, what is the difference between the Exports(as % of merchandise exports) of Congo (Republic) and Exports(as % of merchandise exports) of Sri Lanka?
Your response must be concise. -7.78. In the year 1984, what is the difference between the Exports(as % of merchandise exports) in Congo (Republic) and Exports(as % of merchandise exports) in Switzerland?
Keep it short and to the point. 1.95. In the year 1984, what is the difference between the Exports(as % of merchandise exports) of Sri Lanka and Exports(as % of merchandise exports) of Switzerland?
Make the answer very short. 9.73. In the year 1985, what is the difference between the Exports(as % of merchandise exports) of High income and Exports(as % of merchandise exports) of Congo (Republic)?
Make the answer very short. 1.18. In the year 1985, what is the difference between the Exports(as % of merchandise exports) of High income and Exports(as % of merchandise exports) of Sri Lanka?
Your response must be concise. -6.92. In the year 1985, what is the difference between the Exports(as % of merchandise exports) in High income and Exports(as % of merchandise exports) in Switzerland?
Keep it short and to the point. 1.86. In the year 1985, what is the difference between the Exports(as % of merchandise exports) of Congo (Republic) and Exports(as % of merchandise exports) of Sri Lanka?
Provide a short and direct response. -8.1. In the year 1985, what is the difference between the Exports(as % of merchandise exports) of Congo (Republic) and Exports(as % of merchandise exports) of Switzerland?
Your response must be concise. 0.69. In the year 1985, what is the difference between the Exports(as % of merchandise exports) in Sri Lanka and Exports(as % of merchandise exports) in Switzerland?
Your response must be concise. 8.79. In the year 1986, what is the difference between the Exports(as % of merchandise exports) in High income and Exports(as % of merchandise exports) in Congo (Republic)?
Offer a very short reply. -3.76. In the year 1986, what is the difference between the Exports(as % of merchandise exports) in High income and Exports(as % of merchandise exports) in Sri Lanka?
Provide a short and direct response. -7.44. In the year 1986, what is the difference between the Exports(as % of merchandise exports) of High income and Exports(as % of merchandise exports) of Switzerland?
Offer a very short reply. 2.11. In the year 1986, what is the difference between the Exports(as % of merchandise exports) in Congo (Republic) and Exports(as % of merchandise exports) in Sri Lanka?
Your answer should be compact. -3.68. In the year 1986, what is the difference between the Exports(as % of merchandise exports) in Congo (Republic) and Exports(as % of merchandise exports) in Switzerland?
Give a very brief answer. 5.88. In the year 1986, what is the difference between the Exports(as % of merchandise exports) in Sri Lanka and Exports(as % of merchandise exports) in Switzerland?
Give a very brief answer. 9.56. In the year 1993, what is the difference between the Exports(as % of merchandise exports) in High income and Exports(as % of merchandise exports) in Congo (Republic)?
Give a very brief answer. 0.35. In the year 1993, what is the difference between the Exports(as % of merchandise exports) of High income and Exports(as % of merchandise exports) of Sri Lanka?
Keep it short and to the point. -1.22. In the year 1993, what is the difference between the Exports(as % of merchandise exports) of High income and Exports(as % of merchandise exports) of Switzerland?
Offer a very short reply. 1.55. In the year 1993, what is the difference between the Exports(as % of merchandise exports) in Congo (Republic) and Exports(as % of merchandise exports) in Sri Lanka?
Your response must be concise. -1.58. In the year 1993, what is the difference between the Exports(as % of merchandise exports) of Congo (Republic) and Exports(as % of merchandise exports) of Switzerland?
Give a very brief answer. 1.2. In the year 1993, what is the difference between the Exports(as % of merchandise exports) of Sri Lanka and Exports(as % of merchandise exports) of Switzerland?
Offer a very short reply. 2.78. What is the ratio of the Exports(as % of merchandise exports) of High income in 1979 to that in 1980?
Give a very brief answer. 1.07. What is the ratio of the Exports(as % of merchandise exports) of Congo (Republic) in 1979 to that in 1980?
Make the answer very short. 1.49. What is the ratio of the Exports(as % of merchandise exports) of Sri Lanka in 1979 to that in 1980?
Offer a very short reply. 1.07. What is the ratio of the Exports(as % of merchandise exports) of Switzerland in 1979 to that in 1980?
Give a very brief answer. 1.06. What is the ratio of the Exports(as % of merchandise exports) in High income in 1979 to that in 1983?
Offer a very short reply. 1.24. What is the ratio of the Exports(as % of merchandise exports) in Congo (Republic) in 1979 to that in 1983?
Keep it short and to the point. 1.77. What is the ratio of the Exports(as % of merchandise exports) of Sri Lanka in 1979 to that in 1983?
Provide a short and direct response. 1.4. What is the ratio of the Exports(as % of merchandise exports) of Switzerland in 1979 to that in 1983?
Offer a terse response. 1.2. What is the ratio of the Exports(as % of merchandise exports) of High income in 1979 to that in 1984?
Your response must be concise. 1.21. What is the ratio of the Exports(as % of merchandise exports) in Congo (Republic) in 1979 to that in 1984?
Give a very brief answer. 1.24. What is the ratio of the Exports(as % of merchandise exports) in Sri Lanka in 1979 to that in 1984?
Your answer should be compact. 1.8. What is the ratio of the Exports(as % of merchandise exports) in Switzerland in 1979 to that in 1984?
Give a very brief answer. 1.09. What is the ratio of the Exports(as % of merchandise exports) in High income in 1979 to that in 1985?
Make the answer very short. 1.32. What is the ratio of the Exports(as % of merchandise exports) of Congo (Republic) in 1979 to that in 1985?
Your answer should be compact. 2.22. What is the ratio of the Exports(as % of merchandise exports) of Sri Lanka in 1979 to that in 1985?
Keep it short and to the point. 1.98. What is the ratio of the Exports(as % of merchandise exports) of Switzerland in 1979 to that in 1985?
Give a very brief answer. 1.15. What is the ratio of the Exports(as % of merchandise exports) in High income in 1979 to that in 1986?
Offer a terse response. 1.25. What is the ratio of the Exports(as % of merchandise exports) in Congo (Republic) in 1979 to that in 1986?
Provide a succinct answer. 0.55. What is the ratio of the Exports(as % of merchandise exports) of Sri Lanka in 1979 to that in 1986?
Offer a very short reply. 1.85. What is the ratio of the Exports(as % of merchandise exports) in Switzerland in 1979 to that in 1986?
Keep it short and to the point. 1.25. What is the ratio of the Exports(as % of merchandise exports) of High income in 1979 to that in 1993?
Your answer should be very brief. 1.71. What is the ratio of the Exports(as % of merchandise exports) in Congo (Republic) in 1979 to that in 1993?
Offer a terse response. 2.01. What is the ratio of the Exports(as % of merchandise exports) in Sri Lanka in 1979 to that in 1993?
Your answer should be very brief. 5.66. What is the ratio of the Exports(as % of merchandise exports) of Switzerland in 1979 to that in 1993?
Give a very brief answer. 1.75. What is the ratio of the Exports(as % of merchandise exports) in High income in 1980 to that in 1983?
Your response must be concise. 1.15. What is the ratio of the Exports(as % of merchandise exports) of Congo (Republic) in 1980 to that in 1983?
Your response must be concise. 1.18. What is the ratio of the Exports(as % of merchandise exports) in Sri Lanka in 1980 to that in 1983?
Your answer should be very brief. 1.31. What is the ratio of the Exports(as % of merchandise exports) in Switzerland in 1980 to that in 1983?
Offer a terse response. 1.13. What is the ratio of the Exports(as % of merchandise exports) in High income in 1980 to that in 1984?
Provide a succinct answer. 1.13. What is the ratio of the Exports(as % of merchandise exports) of Congo (Republic) in 1980 to that in 1984?
Make the answer very short. 0.83. What is the ratio of the Exports(as % of merchandise exports) in Sri Lanka in 1980 to that in 1984?
Offer a very short reply. 1.68. What is the ratio of the Exports(as % of merchandise exports) of Switzerland in 1980 to that in 1984?
Make the answer very short. 1.02. What is the ratio of the Exports(as % of merchandise exports) of High income in 1980 to that in 1985?
Offer a very short reply. 1.23. What is the ratio of the Exports(as % of merchandise exports) of Congo (Republic) in 1980 to that in 1985?
Give a very brief answer. 1.48. What is the ratio of the Exports(as % of merchandise exports) in Sri Lanka in 1980 to that in 1985?
Your answer should be compact. 1.85. What is the ratio of the Exports(as % of merchandise exports) of Switzerland in 1980 to that in 1985?
Give a very brief answer. 1.08. What is the ratio of the Exports(as % of merchandise exports) of High income in 1980 to that in 1986?
Your response must be concise. 1.16. What is the ratio of the Exports(as % of merchandise exports) in Congo (Republic) in 1980 to that in 1986?
Provide a short and direct response. 0.37. What is the ratio of the Exports(as % of merchandise exports) in Sri Lanka in 1980 to that in 1986?
Make the answer very short. 1.73. What is the ratio of the Exports(as % of merchandise exports) in Switzerland in 1980 to that in 1986?
Keep it short and to the point. 1.18. What is the ratio of the Exports(as % of merchandise exports) of High income in 1980 to that in 1993?
Your response must be concise. 1.59. What is the ratio of the Exports(as % of merchandise exports) in Congo (Republic) in 1980 to that in 1993?
Offer a very short reply. 1.35. What is the ratio of the Exports(as % of merchandise exports) in Sri Lanka in 1980 to that in 1993?
Give a very brief answer. 5.29. What is the ratio of the Exports(as % of merchandise exports) of Switzerland in 1980 to that in 1993?
Offer a terse response. 1.65. What is the ratio of the Exports(as % of merchandise exports) of High income in 1983 to that in 1984?
Provide a succinct answer. 0.98. What is the ratio of the Exports(as % of merchandise exports) of Congo (Republic) in 1983 to that in 1984?
Your response must be concise. 0.7. What is the ratio of the Exports(as % of merchandise exports) of Sri Lanka in 1983 to that in 1984?
Offer a very short reply. 1.28. What is the ratio of the Exports(as % of merchandise exports) of Switzerland in 1983 to that in 1984?
Ensure brevity in your answer.  0.91. What is the ratio of the Exports(as % of merchandise exports) of High income in 1983 to that in 1985?
Your answer should be very brief. 1.06. What is the ratio of the Exports(as % of merchandise exports) in Congo (Republic) in 1983 to that in 1985?
Your answer should be very brief. 1.25. What is the ratio of the Exports(as % of merchandise exports) of Sri Lanka in 1983 to that in 1985?
Offer a very short reply. 1.41. What is the ratio of the Exports(as % of merchandise exports) in Switzerland in 1983 to that in 1985?
Offer a terse response. 0.96. What is the ratio of the Exports(as % of merchandise exports) in Congo (Republic) in 1983 to that in 1986?
Your response must be concise. 0.31. What is the ratio of the Exports(as % of merchandise exports) of Sri Lanka in 1983 to that in 1986?
Provide a succinct answer. 1.32. What is the ratio of the Exports(as % of merchandise exports) of Switzerland in 1983 to that in 1986?
Offer a very short reply. 1.05. What is the ratio of the Exports(as % of merchandise exports) in High income in 1983 to that in 1993?
Your answer should be very brief. 1.38. What is the ratio of the Exports(as % of merchandise exports) of Congo (Republic) in 1983 to that in 1993?
Make the answer very short. 1.14. What is the ratio of the Exports(as % of merchandise exports) of Sri Lanka in 1983 to that in 1993?
Your answer should be compact. 4.03. What is the ratio of the Exports(as % of merchandise exports) of Switzerland in 1983 to that in 1993?
Provide a short and direct response. 1.46. What is the ratio of the Exports(as % of merchandise exports) of High income in 1984 to that in 1985?
Provide a short and direct response. 1.09. What is the ratio of the Exports(as % of merchandise exports) of Congo (Republic) in 1984 to that in 1985?
Provide a short and direct response. 1.78. What is the ratio of the Exports(as % of merchandise exports) in Sri Lanka in 1984 to that in 1985?
Your answer should be compact. 1.1. What is the ratio of the Exports(as % of merchandise exports) of Switzerland in 1984 to that in 1985?
Your response must be concise. 1.06. What is the ratio of the Exports(as % of merchandise exports) of High income in 1984 to that in 1986?
Offer a very short reply. 1.03. What is the ratio of the Exports(as % of merchandise exports) in Congo (Republic) in 1984 to that in 1986?
Your response must be concise. 0.44. What is the ratio of the Exports(as % of merchandise exports) in Sri Lanka in 1984 to that in 1986?
Provide a succinct answer. 1.03. What is the ratio of the Exports(as % of merchandise exports) in Switzerland in 1984 to that in 1986?
Offer a very short reply. 1.15. What is the ratio of the Exports(as % of merchandise exports) of High income in 1984 to that in 1993?
Your answer should be compact. 1.41. What is the ratio of the Exports(as % of merchandise exports) in Congo (Republic) in 1984 to that in 1993?
Give a very brief answer. 1.62. What is the ratio of the Exports(as % of merchandise exports) in Sri Lanka in 1984 to that in 1993?
Your answer should be very brief. 3.15. What is the ratio of the Exports(as % of merchandise exports) of Switzerland in 1984 to that in 1993?
Keep it short and to the point. 1.61. What is the ratio of the Exports(as % of merchandise exports) in High income in 1985 to that in 1986?
Offer a very short reply. 0.94. What is the ratio of the Exports(as % of merchandise exports) in Congo (Republic) in 1985 to that in 1986?
Ensure brevity in your answer.  0.25. What is the ratio of the Exports(as % of merchandise exports) of Sri Lanka in 1985 to that in 1986?
Give a very brief answer. 0.93. What is the ratio of the Exports(as % of merchandise exports) in Switzerland in 1985 to that in 1986?
Offer a very short reply. 1.09. What is the ratio of the Exports(as % of merchandise exports) of High income in 1985 to that in 1993?
Your answer should be very brief. 1.3. What is the ratio of the Exports(as % of merchandise exports) in Congo (Republic) in 1985 to that in 1993?
Ensure brevity in your answer.  0.91. What is the ratio of the Exports(as % of merchandise exports) of Sri Lanka in 1985 to that in 1993?
Your answer should be very brief. 2.85. What is the ratio of the Exports(as % of merchandise exports) in Switzerland in 1985 to that in 1993?
Your answer should be compact. 1.52. What is the ratio of the Exports(as % of merchandise exports) of High income in 1986 to that in 1993?
Your answer should be very brief. 1.37. What is the ratio of the Exports(as % of merchandise exports) of Congo (Republic) in 1986 to that in 1993?
Provide a succinct answer. 3.67. What is the ratio of the Exports(as % of merchandise exports) of Sri Lanka in 1986 to that in 1993?
Your response must be concise. 3.06. What is the ratio of the Exports(as % of merchandise exports) of Switzerland in 1986 to that in 1993?
Your answer should be compact. 1.4. What is the difference between the highest and the second highest Exports(as % of merchandise exports) of High income?
Your answer should be compact. 0.26. What is the difference between the highest and the second highest Exports(as % of merchandise exports) in Congo (Republic)?
Give a very brief answer. 3.06. What is the difference between the highest and the second highest Exports(as % of merchandise exports) of Sri Lanka?
Your answer should be compact. 1.25. What is the difference between the highest and the second highest Exports(as % of merchandise exports) of Switzerland?
Make the answer very short. 0.07. What is the difference between the highest and the lowest Exports(as % of merchandise exports) in High income?
Offer a terse response. 1.56. What is the difference between the highest and the lowest Exports(as % of merchandise exports) in Congo (Republic)?
Offer a very short reply. 5.11. What is the difference between the highest and the lowest Exports(as % of merchandise exports) of Sri Lanka?
Ensure brevity in your answer.  15.96. What is the difference between the highest and the lowest Exports(as % of merchandise exports) of Switzerland?
Ensure brevity in your answer.  0.49. 